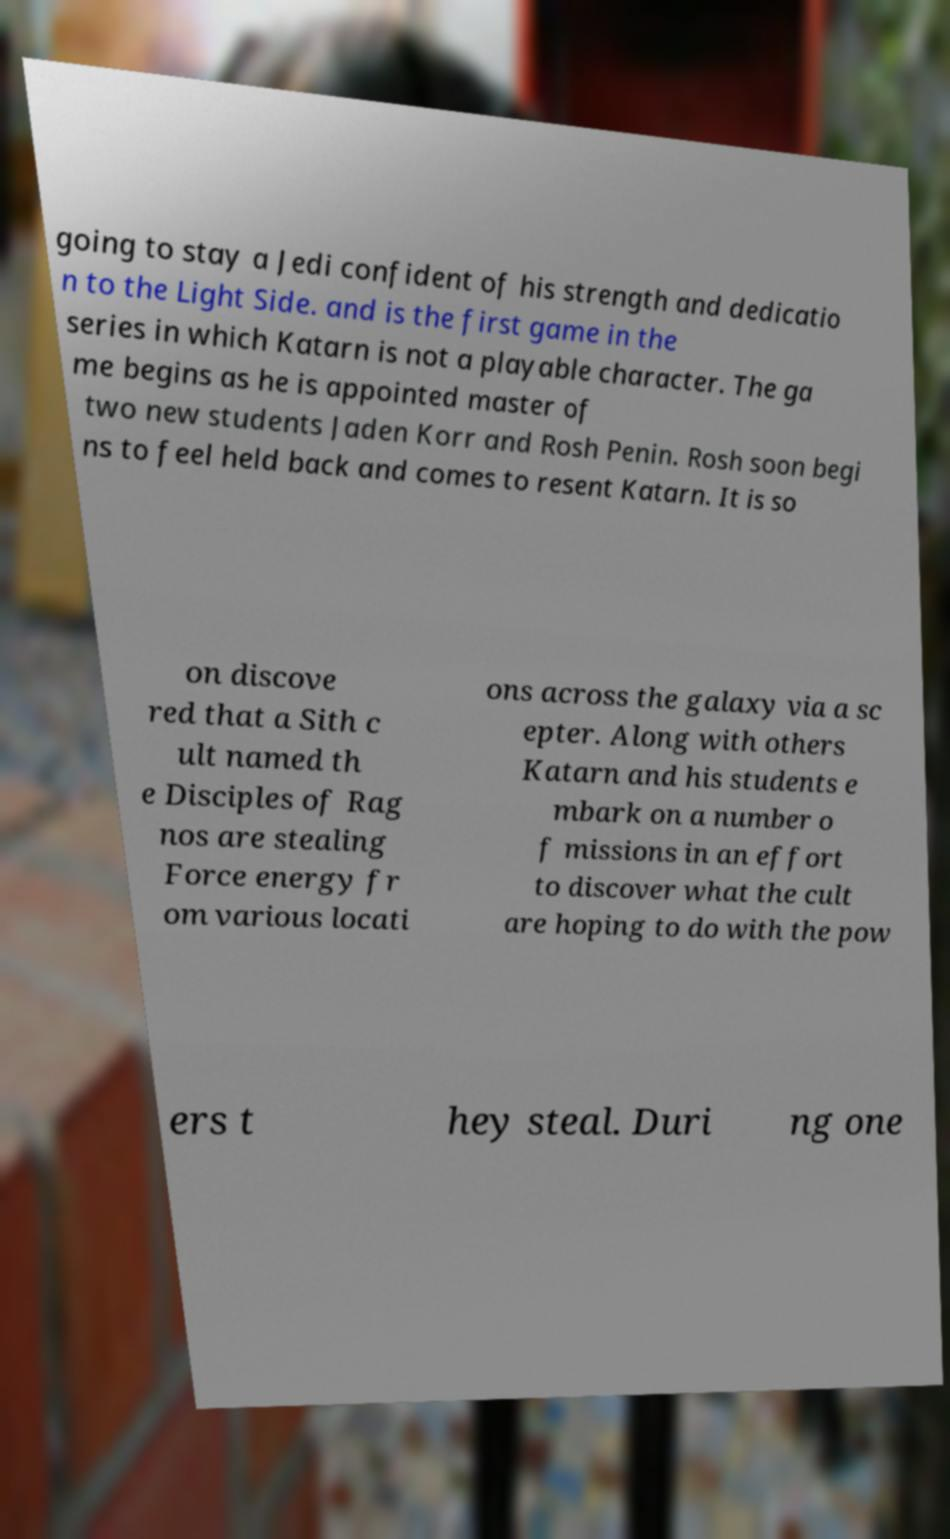Please identify and transcribe the text found in this image. going to stay a Jedi confident of his strength and dedicatio n to the Light Side. and is the first game in the series in which Katarn is not a playable character. The ga me begins as he is appointed master of two new students Jaden Korr and Rosh Penin. Rosh soon begi ns to feel held back and comes to resent Katarn. It is so on discove red that a Sith c ult named th e Disciples of Rag nos are stealing Force energy fr om various locati ons across the galaxy via a sc epter. Along with others Katarn and his students e mbark on a number o f missions in an effort to discover what the cult are hoping to do with the pow ers t hey steal. Duri ng one 